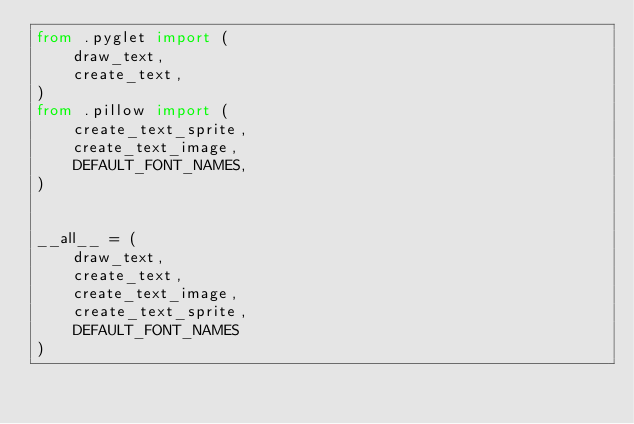Convert code to text. <code><loc_0><loc_0><loc_500><loc_500><_Python_>from .pyglet import (
    draw_text,
    create_text,
)
from .pillow import (
    create_text_sprite,
    create_text_image,
    DEFAULT_FONT_NAMES,
)


__all__ = (
    draw_text,
    create_text,
    create_text_image,
    create_text_sprite,
    DEFAULT_FONT_NAMES
)
</code> 